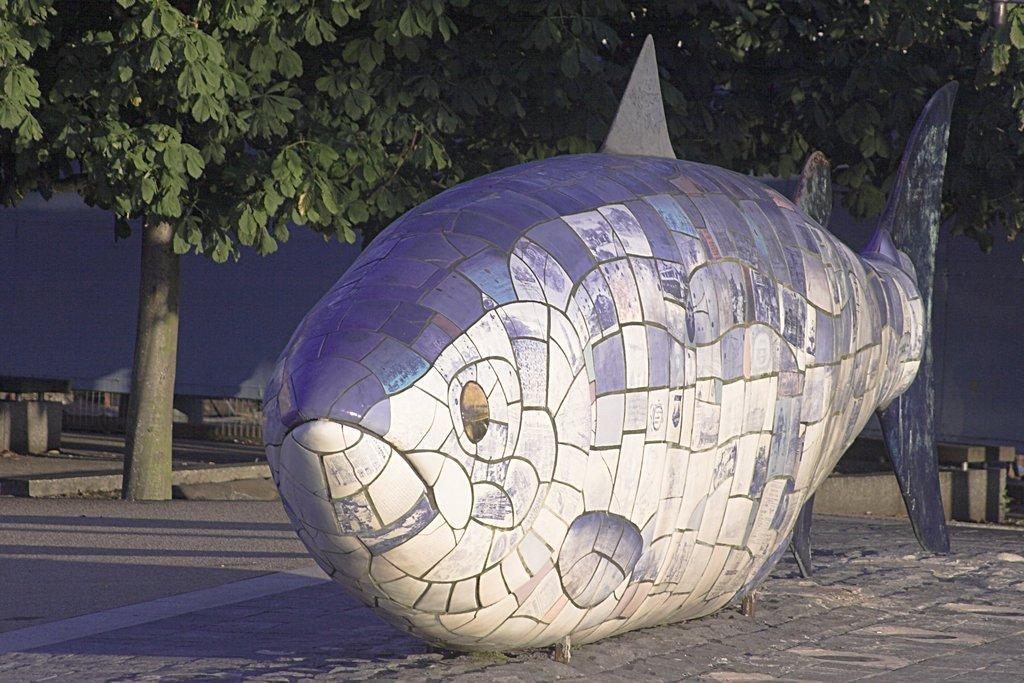Describe this image in one or two sentences. In the center of the image we can see a sculpture. In the background there are trees and we can see a fence. 